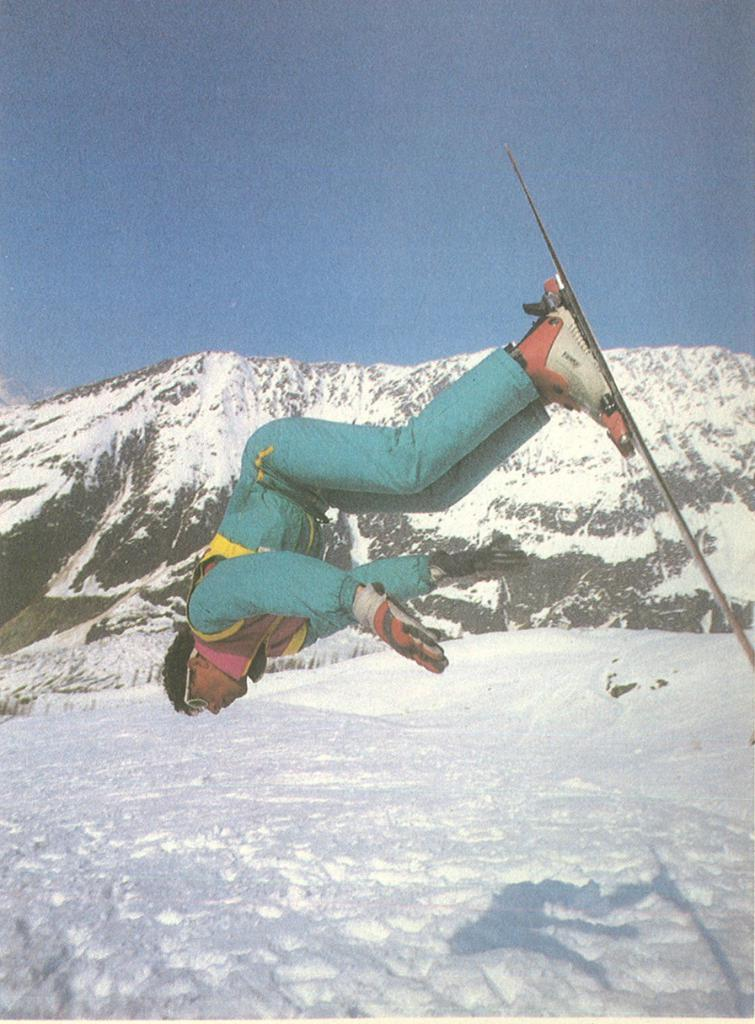What is the main subject of the image? There is a man in the image. What is the man doing in the image? The man is jumping with a ski board. What is the man wearing in the image? The man is wearing a costume. What type of terrain is visible in the image? There is snow visible in the image. What can be seen in the background of the image? There are mountains and the sky visible in the background of the image. How much sugar is present in the costume the man is wearing in the image? There is no sugar present in the costume the man is wearing in the image. What type of plastic material can be seen in the image? There is no plastic material visible in the image. 